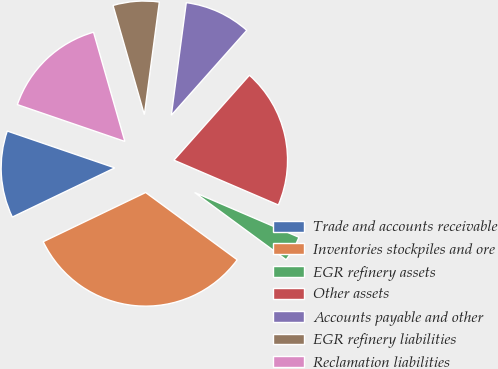Convert chart. <chart><loc_0><loc_0><loc_500><loc_500><pie_chart><fcel>Trade and accounts receivable<fcel>Inventories stockpiles and ore<fcel>EGR refinery assets<fcel>Other assets<fcel>Accounts payable and other<fcel>EGR refinery liabilities<fcel>Reclamation liabilities<nl><fcel>12.38%<fcel>32.79%<fcel>3.63%<fcel>19.89%<fcel>9.46%<fcel>6.55%<fcel>15.3%<nl></chart> 